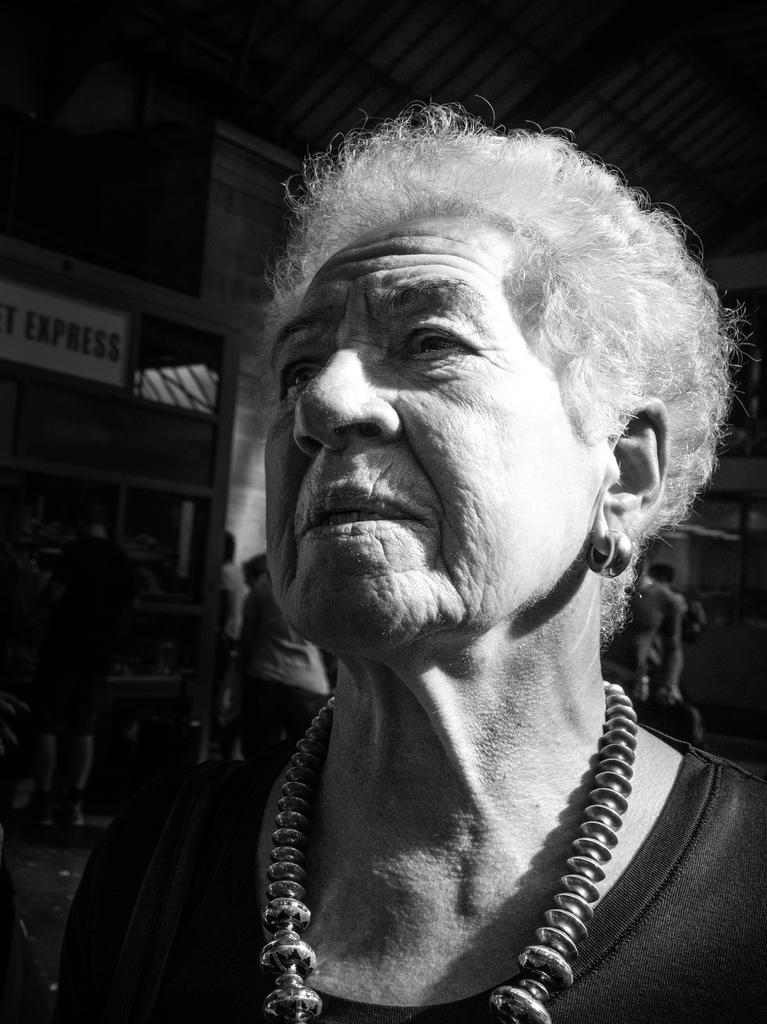What is the main subject of the image? There is a person in the image. Are there any other people in the image? Yes, there is a group of persons behind the person. What type of structure is visible in the image? There is a wall visible in the image. What part of a building can be seen at the top of the image? The roof is visible at the top of the image. What color is the notebook that the person is holding in the image? There is no notebook present in the image. Can you describe the orange that the person is peeling in the image? There is no orange present in the image. 